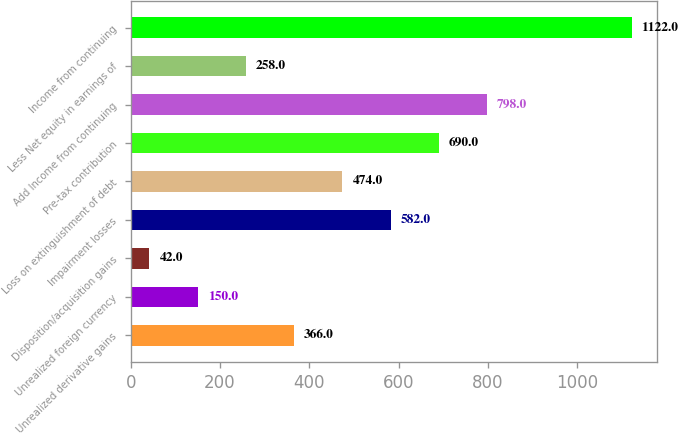<chart> <loc_0><loc_0><loc_500><loc_500><bar_chart><fcel>Unrealized derivative gains<fcel>Unrealized foreign currency<fcel>Disposition/acquisition gains<fcel>Impairment losses<fcel>Loss on extinguishment of debt<fcel>Pre-tax contribution<fcel>Add Income from continuing<fcel>Less Net equity in earnings of<fcel>Income from continuing<nl><fcel>366<fcel>150<fcel>42<fcel>582<fcel>474<fcel>690<fcel>798<fcel>258<fcel>1122<nl></chart> 